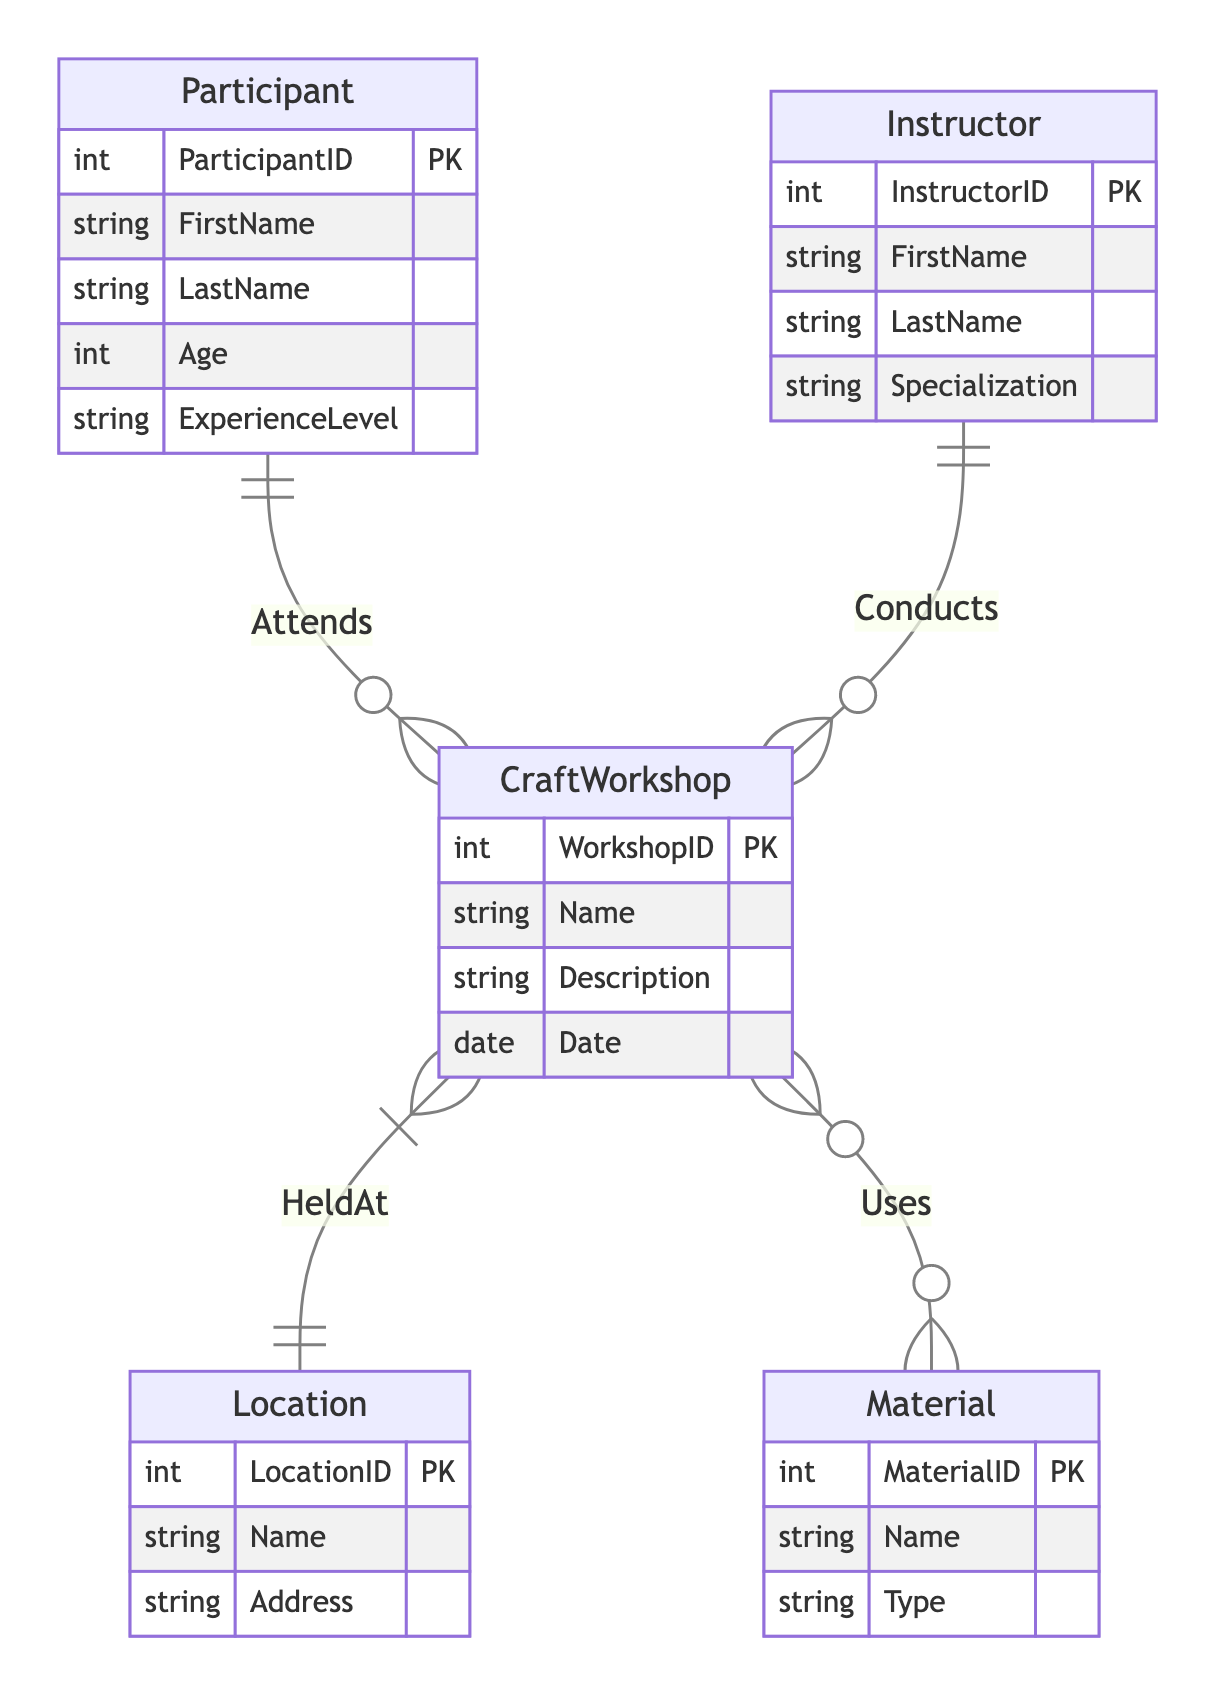What is the primary unique identifier for a Participant? The primary unique identifier for a Participant is the ParticipantID attribute, which is designated as the primary key (PK) in the diagram.
Answer: ParticipantID How many entities are involved in the CraftWorkshop relationship? The CraftWorkshop relationship "Attends" connects with two entities: Participant and CraftWorkshop. Thus, there are two entities involved in this relationship.
Answer: 2 What attribute specifies the location where a CraftWorkshop is held? The attribute that specifies the location where a CraftWorkshop is held is the Location entity, particularly the Name attribute which indicates the name of the location.
Answer: Name Can a CraftWorkshop use multiple Materials? Yes, a CraftWorkshop can use multiple Materials since the relationship "Uses" indicates a many-to-many relationship with the Material entity due to the 'o{ and }o' notation.
Answer: Yes Which entity is responsible for conducting a CraftWorkshop? The Instructor entity is responsible for conducting a CraftWorkshop, as indicated by the "Conducts" relationship from the Instructor to CraftWorkshop.
Answer: Instructor What kind of relationship is established between CraftWorkshop and Material? The relationship between CraftWorkshop and Material is a many-to-many relationship since it is represented by using 'o{ and }o' notation in the diagram, indicating that one CraftWorkshop can use multiple Materials and vice versa.
Answer: Many-to-many How many attributes are present in the Instructor entity? The Instructor entity has four attributes: InstructorID, FirstName, LastName, and Specialization, making a total of four attributes.
Answer: 4 What does the Description attribute in CraftWorkshop signify? The Description attribute in the CraftWorkshop entity provides detailed information regarding the nature or content of the workshop, allowing participants to understand what to expect.
Answer: Detailed information Which entity shares the most relationships based on the diagram? The CraftWorkshop entity shares relationships with multiple entities: Attends (Participant), Conducts (Instructor), HeldAt (Location), and Uses (Material), making it the central entity with the most relationships.
Answer: CraftWorkshop 